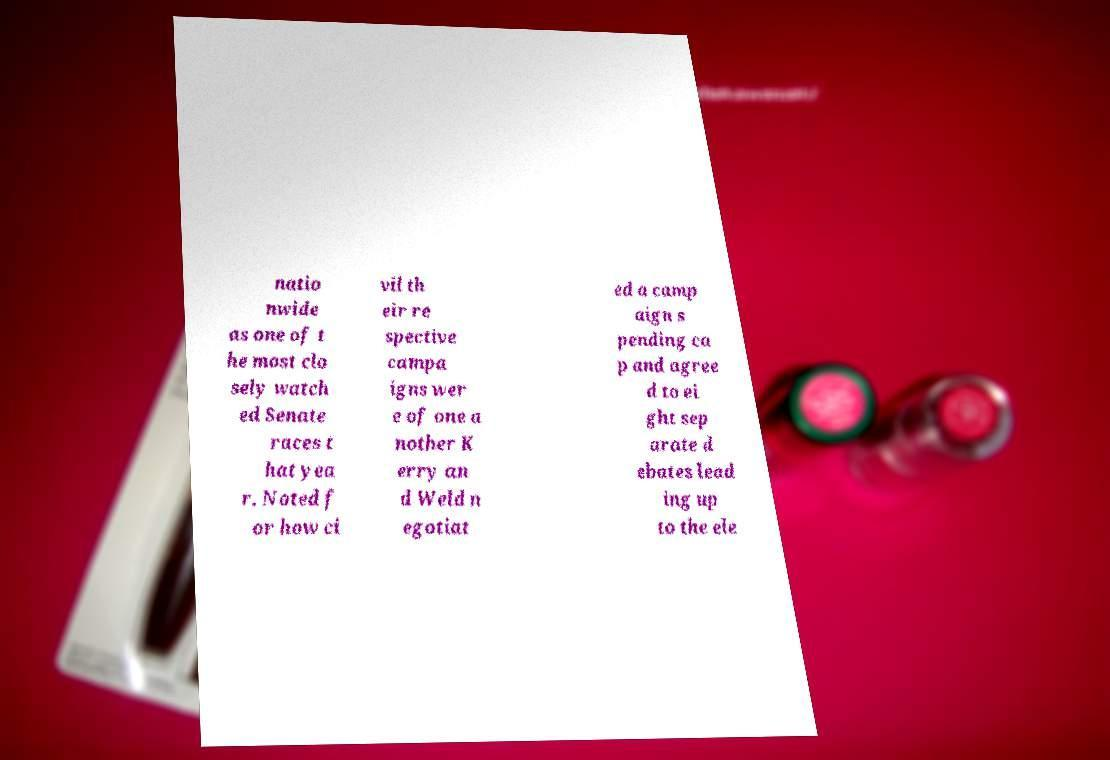Can you read and provide the text displayed in the image?This photo seems to have some interesting text. Can you extract and type it out for me? natio nwide as one of t he most clo sely watch ed Senate races t hat yea r. Noted f or how ci vil th eir re spective campa igns wer e of one a nother K erry an d Weld n egotiat ed a camp aign s pending ca p and agree d to ei ght sep arate d ebates lead ing up to the ele 